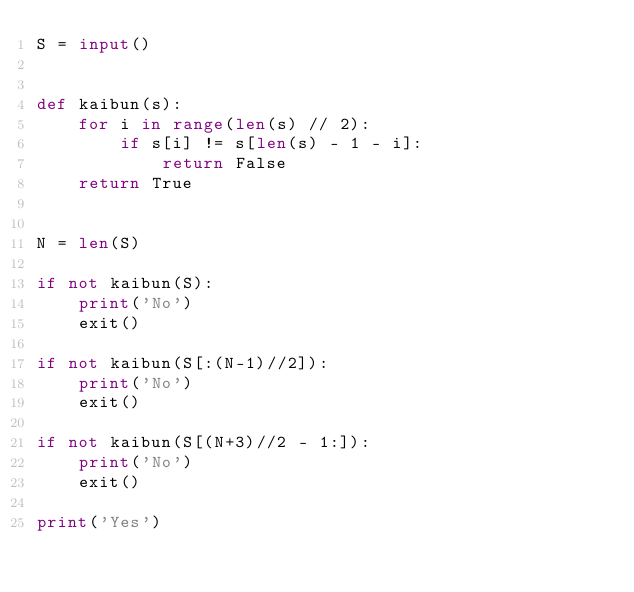Convert code to text. <code><loc_0><loc_0><loc_500><loc_500><_Python_>S = input()


def kaibun(s):
    for i in range(len(s) // 2):
        if s[i] != s[len(s) - 1 - i]:
            return False
    return True


N = len(S)

if not kaibun(S):
    print('No')
    exit()
    
if not kaibun(S[:(N-1)//2]):
    print('No')
    exit()

if not kaibun(S[(N+3)//2 - 1:]):
    print('No')
    exit()

print('Yes')
</code> 